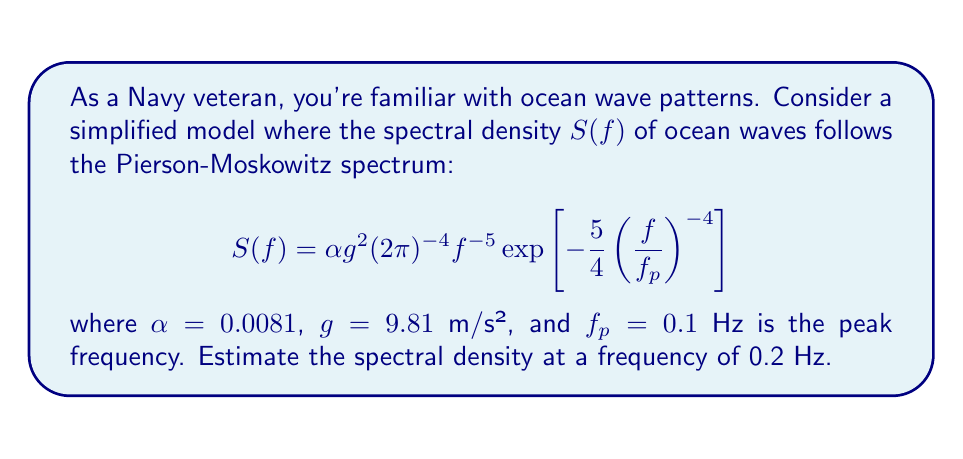Provide a solution to this math problem. To estimate the spectral density at $f = 0.2$ Hz, we'll follow these steps:

1) Start with the given Pierson-Moskowitz spectrum formula:
   $$S(f) = \alpha g^2 (2\pi)^{-4} f^{-5} \exp\left[-\frac{5}{4}\left(\frac{f}{f_p}\right)^{-4}\right]$$

2) Substitute the known values:
   $\alpha = 0.0081$
   $g = 9.81$ m/s²
   $f_p = 0.1$ Hz
   $f = 0.2$ Hz

3) Calculate $(2\pi)^{-4}$:
   $(2\pi)^{-4} \approx 6.33 \times 10^{-6}$

4) Calculate $f^{-5}$:
   $(0.2)^{-5} = 3125$

5) Calculate $\left(\frac{f}{f_p}\right)^{-4}$:
   $\left(\frac{0.2}{0.1}\right)^{-4} = (2)^{-4} = \frac{1}{16}$

6) Calculate the exponent:
   $\exp\left[-\frac{5}{4}\left(\frac{1}{16}\right)\right] \approx 0.9247$

7) Put it all together:
   $S(0.2) = 0.0081 \times (9.81)^2 \times (6.33 \times 10^{-6}) \times 3125 \times 0.9247$

8) Compute the final result:
   $S(0.2) \approx 1.4678$ m²/Hz
Answer: $1.47$ m²/Hz 